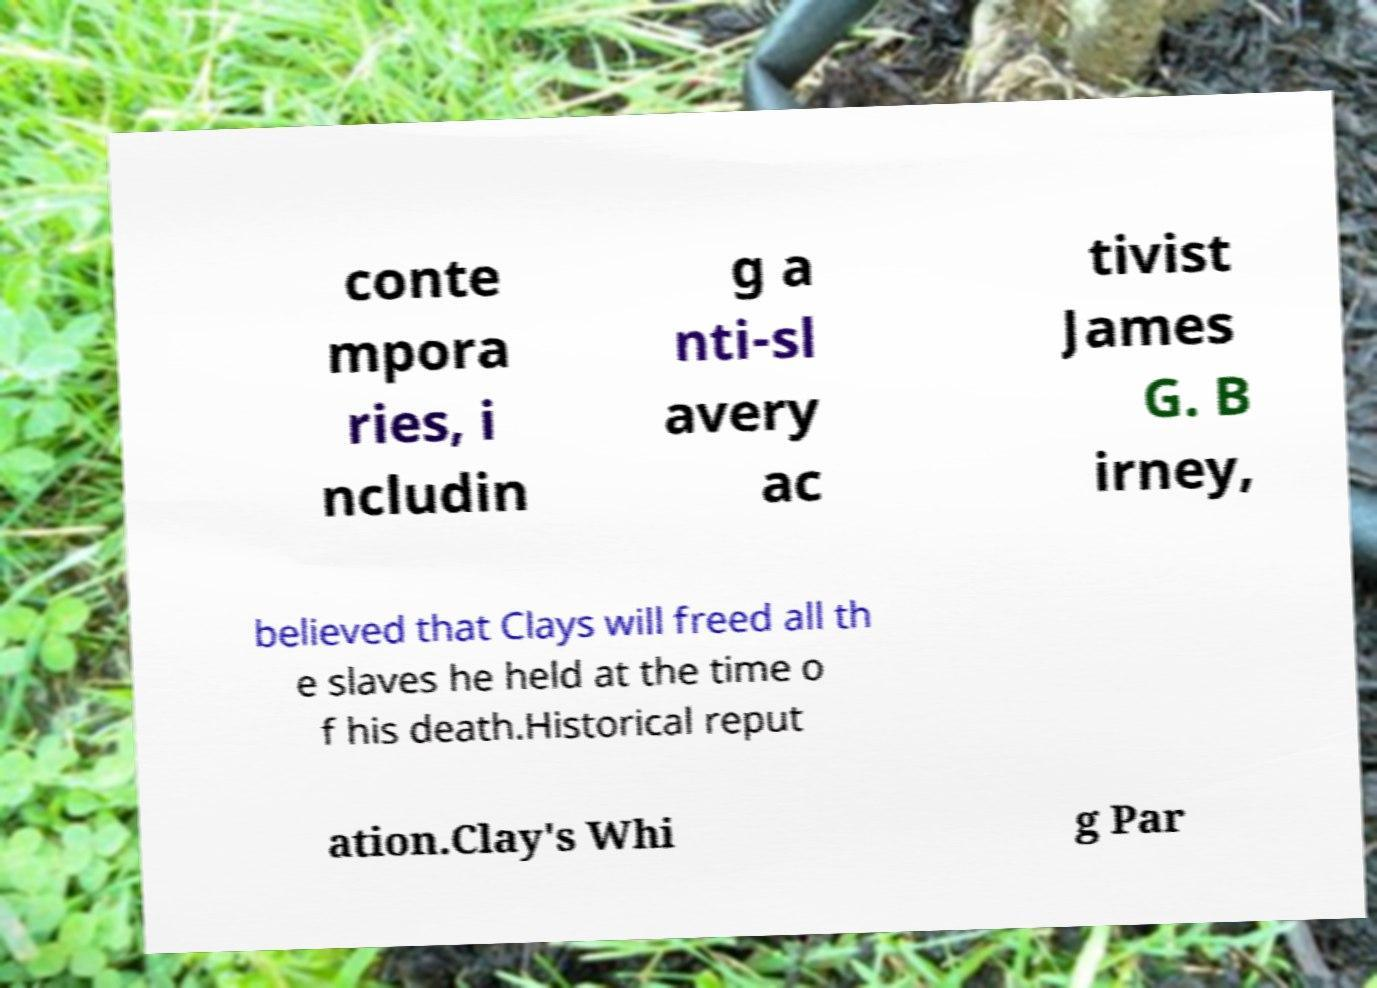Could you extract and type out the text from this image? conte mpora ries, i ncludin g a nti-sl avery ac tivist James G. B irney, believed that Clays will freed all th e slaves he held at the time o f his death.Historical reput ation.Clay's Whi g Par 